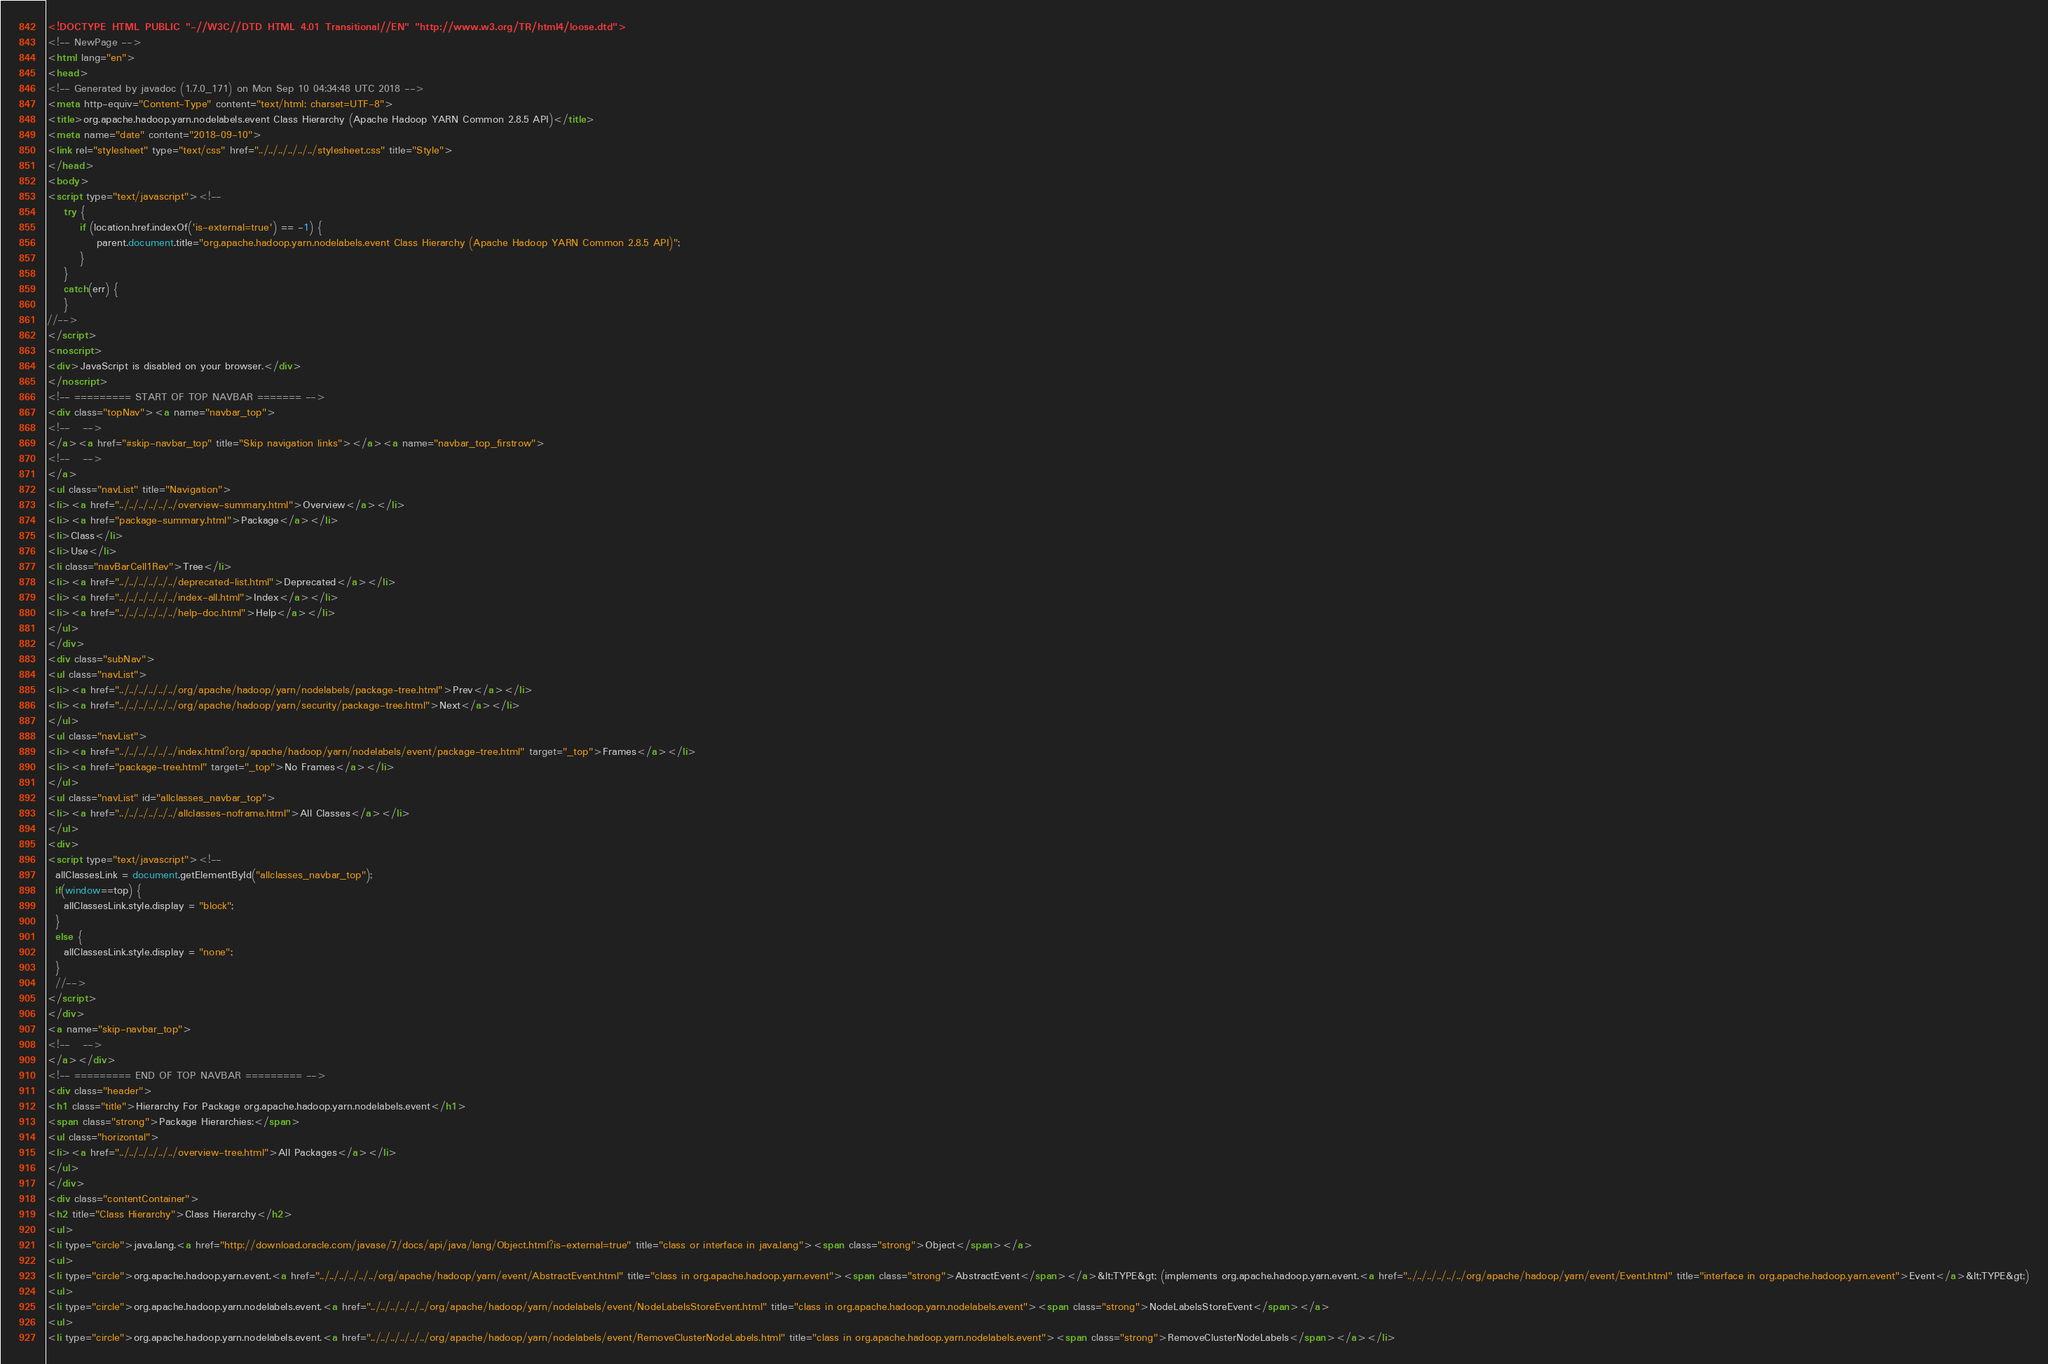<code> <loc_0><loc_0><loc_500><loc_500><_HTML_><!DOCTYPE HTML PUBLIC "-//W3C//DTD HTML 4.01 Transitional//EN" "http://www.w3.org/TR/html4/loose.dtd">
<!-- NewPage -->
<html lang="en">
<head>
<!-- Generated by javadoc (1.7.0_171) on Mon Sep 10 04:34:48 UTC 2018 -->
<meta http-equiv="Content-Type" content="text/html; charset=UTF-8">
<title>org.apache.hadoop.yarn.nodelabels.event Class Hierarchy (Apache Hadoop YARN Common 2.8.5 API)</title>
<meta name="date" content="2018-09-10">
<link rel="stylesheet" type="text/css" href="../../../../../../stylesheet.css" title="Style">
</head>
<body>
<script type="text/javascript"><!--
    try {
        if (location.href.indexOf('is-external=true') == -1) {
            parent.document.title="org.apache.hadoop.yarn.nodelabels.event Class Hierarchy (Apache Hadoop YARN Common 2.8.5 API)";
        }
    }
    catch(err) {
    }
//-->
</script>
<noscript>
<div>JavaScript is disabled on your browser.</div>
</noscript>
<!-- ========= START OF TOP NAVBAR ======= -->
<div class="topNav"><a name="navbar_top">
<!--   -->
</a><a href="#skip-navbar_top" title="Skip navigation links"></a><a name="navbar_top_firstrow">
<!--   -->
</a>
<ul class="navList" title="Navigation">
<li><a href="../../../../../../overview-summary.html">Overview</a></li>
<li><a href="package-summary.html">Package</a></li>
<li>Class</li>
<li>Use</li>
<li class="navBarCell1Rev">Tree</li>
<li><a href="../../../../../../deprecated-list.html">Deprecated</a></li>
<li><a href="../../../../../../index-all.html">Index</a></li>
<li><a href="../../../../../../help-doc.html">Help</a></li>
</ul>
</div>
<div class="subNav">
<ul class="navList">
<li><a href="../../../../../../org/apache/hadoop/yarn/nodelabels/package-tree.html">Prev</a></li>
<li><a href="../../../../../../org/apache/hadoop/yarn/security/package-tree.html">Next</a></li>
</ul>
<ul class="navList">
<li><a href="../../../../../../index.html?org/apache/hadoop/yarn/nodelabels/event/package-tree.html" target="_top">Frames</a></li>
<li><a href="package-tree.html" target="_top">No Frames</a></li>
</ul>
<ul class="navList" id="allclasses_navbar_top">
<li><a href="../../../../../../allclasses-noframe.html">All Classes</a></li>
</ul>
<div>
<script type="text/javascript"><!--
  allClassesLink = document.getElementById("allclasses_navbar_top");
  if(window==top) {
    allClassesLink.style.display = "block";
  }
  else {
    allClassesLink.style.display = "none";
  }
  //-->
</script>
</div>
<a name="skip-navbar_top">
<!--   -->
</a></div>
<!-- ========= END OF TOP NAVBAR ========= -->
<div class="header">
<h1 class="title">Hierarchy For Package org.apache.hadoop.yarn.nodelabels.event</h1>
<span class="strong">Package Hierarchies:</span>
<ul class="horizontal">
<li><a href="../../../../../../overview-tree.html">All Packages</a></li>
</ul>
</div>
<div class="contentContainer">
<h2 title="Class Hierarchy">Class Hierarchy</h2>
<ul>
<li type="circle">java.lang.<a href="http://download.oracle.com/javase/7/docs/api/java/lang/Object.html?is-external=true" title="class or interface in java.lang"><span class="strong">Object</span></a>
<ul>
<li type="circle">org.apache.hadoop.yarn.event.<a href="../../../../../../org/apache/hadoop/yarn/event/AbstractEvent.html" title="class in org.apache.hadoop.yarn.event"><span class="strong">AbstractEvent</span></a>&lt;TYPE&gt; (implements org.apache.hadoop.yarn.event.<a href="../../../../../../org/apache/hadoop/yarn/event/Event.html" title="interface in org.apache.hadoop.yarn.event">Event</a>&lt;TYPE&gt;)
<ul>
<li type="circle">org.apache.hadoop.yarn.nodelabels.event.<a href="../../../../../../org/apache/hadoop/yarn/nodelabels/event/NodeLabelsStoreEvent.html" title="class in org.apache.hadoop.yarn.nodelabels.event"><span class="strong">NodeLabelsStoreEvent</span></a>
<ul>
<li type="circle">org.apache.hadoop.yarn.nodelabels.event.<a href="../../../../../../org/apache/hadoop/yarn/nodelabels/event/RemoveClusterNodeLabels.html" title="class in org.apache.hadoop.yarn.nodelabels.event"><span class="strong">RemoveClusterNodeLabels</span></a></li></code> 